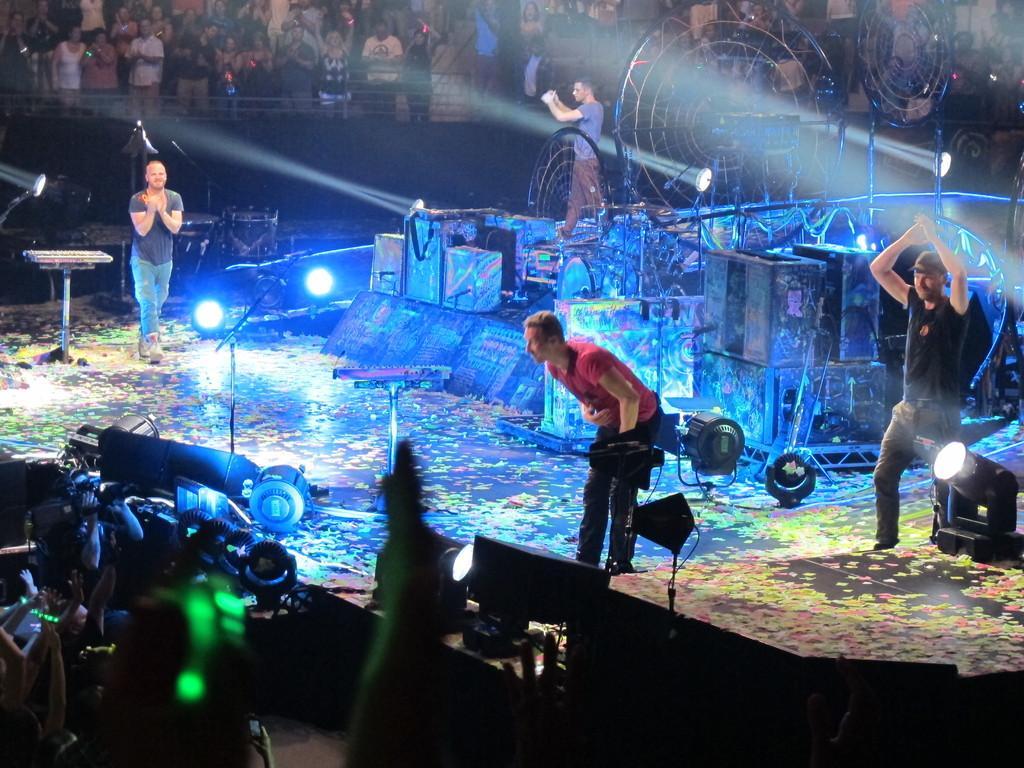In one or two sentences, can you explain what this image depicts? In this image I can see a stage with four people. I can see grills, metal constructions, speakers, papers all over, lights, and a keyboard on the stage. I can see a crew of people at the top of the image. In the bottom left corner I can see a person holding a camera. The background is dark.  